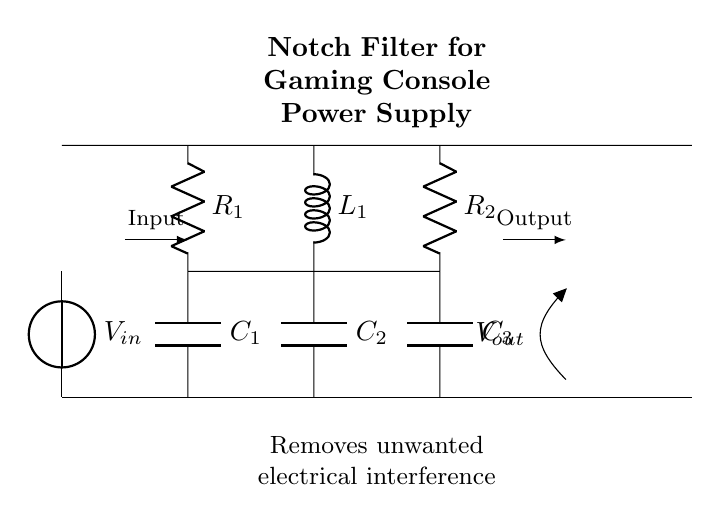What is the input voltage source labeled as? The input voltage source is labeled $V_{in}$, which indicates the voltage supplied to the circuit.
Answer: V_in What components make up the notch filter? The notch filter consists of resistors, capacitors, and an inductor, specifically $R_1$, $R_2$, $C_1$, $C_2$, $C_3$, and $L_1$.
Answer: R_1, R_2, C_1, C_2, C_3, L_1 What is the value of the output voltage labeled as? The output voltage is labeled $V_{out}$, indicating the voltage that appears after the filtering process.
Answer: V_out Which component connects the input to the first resistor? The connecting component is a voltage source, which supplies power to the circuit and connects directly to the first resistor $R_1$.
Answer: Voltage source How many capacitors are used in this circuit? There are three capacitors in the circuit: $C_1$, $C_2$, and $C_3$.
Answer: Three What is the purpose of this notch filter? The purpose of the notch filter is to remove unwanted electrical interference from the gaming console power supplies, improving performance.
Answer: Remove interference How does the inductor affect the filter's performance? The inductor $L_1$ stores energy in a magnetic field and helps to create a notch in the frequency response, specifically attenuating unwanted frequencies.
Answer: Creates frequency notch 